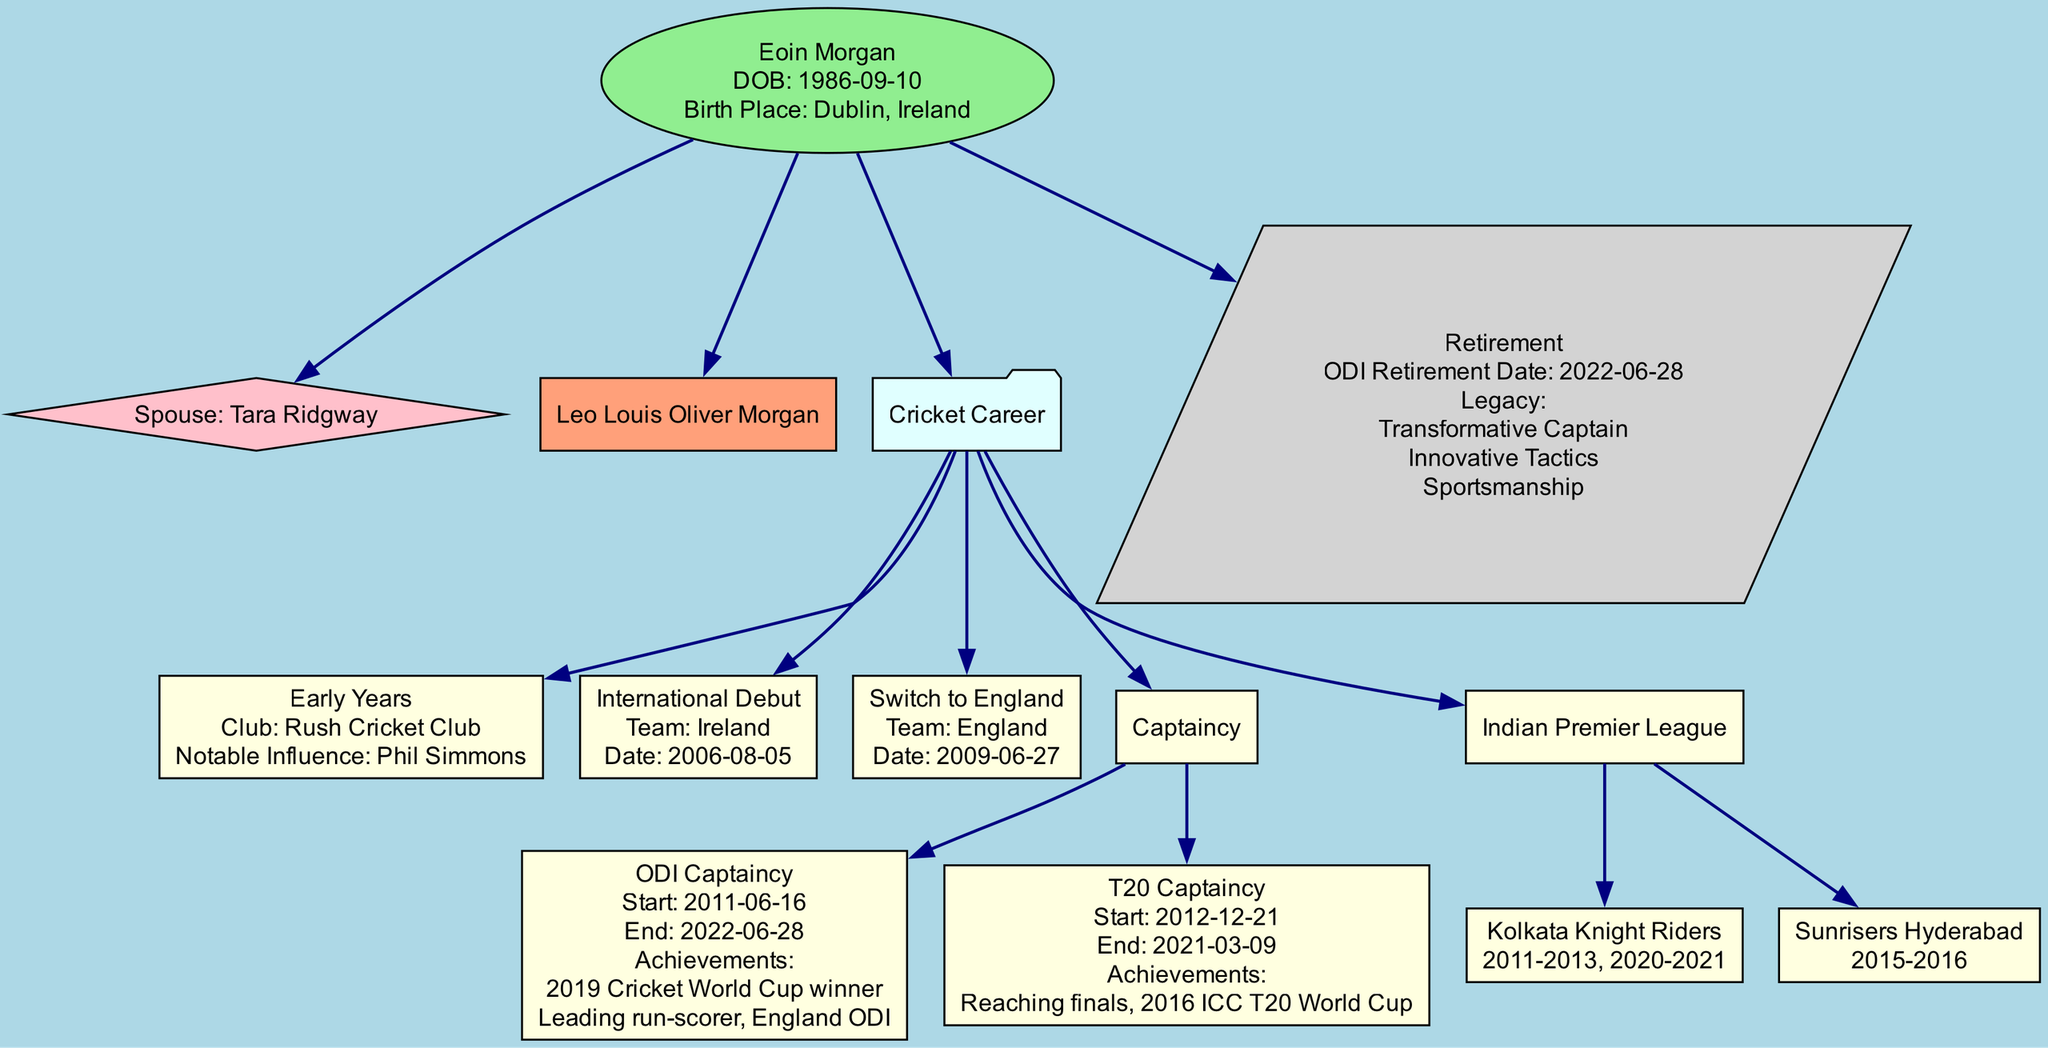What is Eoin Morgan's birthplace? The diagram indicates that Eoin Morgan was born in Dublin, Ireland, as shown under the "Eoin Morgan" node.
Answer: Dublin, Ireland Who is Eoin Morgan's spouse? According to the family section of the diagram, Eoin Morgan's spouse is Tara Ridgway.
Answer: Tara Ridgway In which year did Eoin Morgan make his international debut? The international debut node specifies that Eoin Morgan debuted for Ireland on August 5, 2006. The year can be extracted directly from this date.
Answer: 2006 What was Eoin Morgan's notable achievement as ODI captain? The ODI captaincy node lists "2019 Cricket World Cup winner" among notable achievements, highlighting a significant point in his career.
Answer: 2019 Cricket World Cup winner How many teams did Eoin Morgan play for in the Indian Premier League? The IPL section of the diagram lists two distinct teams: Kolkata Knight Riders and Sunrisers Hyderabad, indicating the number of teams he played for.
Answer: 2 When did Eoin Morgan switch to the England cricket team? The diagram explicitly states that Eoin Morgan switched to the England team on June 27, 2009. This date provides a clear answer to the question.
Answer: June 27, 2009 What is the legacy Eoin Morgan leaves behind after his retirement? The retirement section highlights three aspects of his legacy, namely "Transformative Captain," "Innovative Tactics," and "Sportsmanship." Through careful reading, one can ascertain these qualities.
Answer: Transformative Captain, Innovative Tactics, Sportsmanship What was the end date of Eoin Morgan's ODI captaincy? The diagram specifies that Eoin Morgan's ODI captaincy ended on June 28, 2022, allowing for a direct answer regarding the termination of this role.
Answer: June 28, 2022 Which team did Eoin Morgan captain in T20? The T20 captaincy node mentions the notable achievement of reaching the finals in the 2016 ICC T20 World Cup without specifying a team name. However, it's implied that he captained England in T20s.
Answer: England 